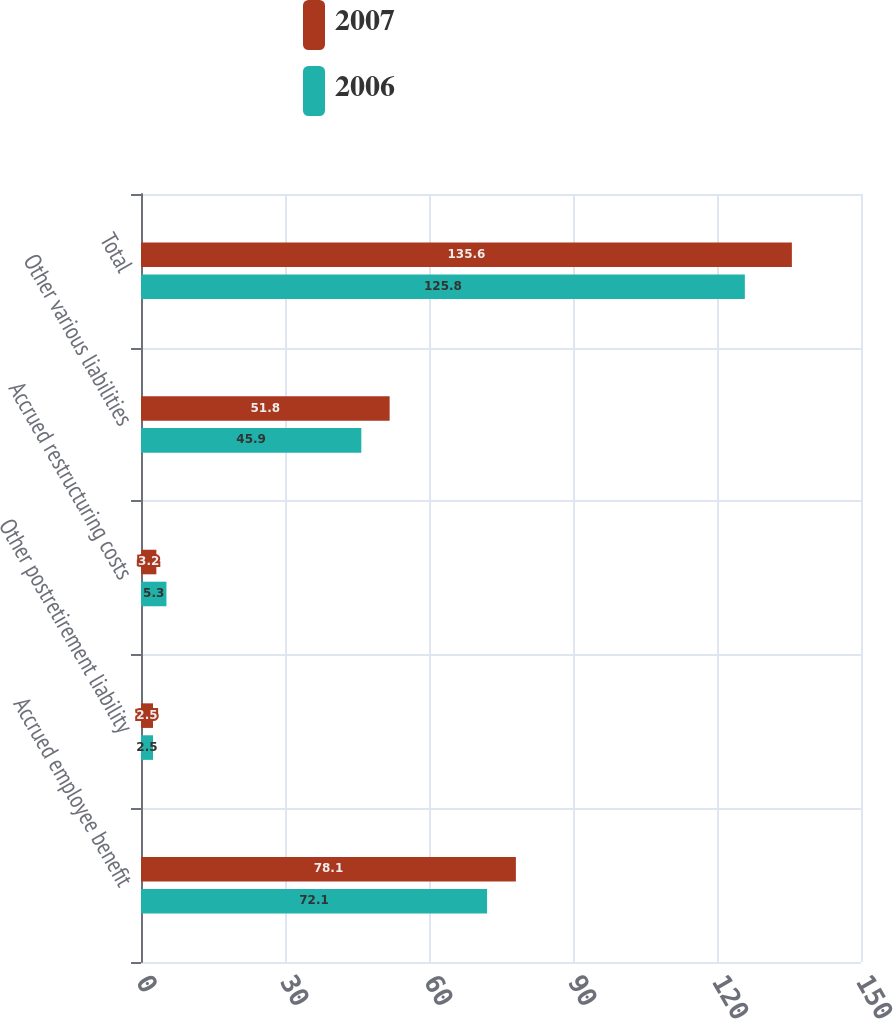Convert chart to OTSL. <chart><loc_0><loc_0><loc_500><loc_500><stacked_bar_chart><ecel><fcel>Accrued employee benefit<fcel>Other postretirement liability<fcel>Accrued restructuring costs<fcel>Other various liabilities<fcel>Total<nl><fcel>2007<fcel>78.1<fcel>2.5<fcel>3.2<fcel>51.8<fcel>135.6<nl><fcel>2006<fcel>72.1<fcel>2.5<fcel>5.3<fcel>45.9<fcel>125.8<nl></chart> 